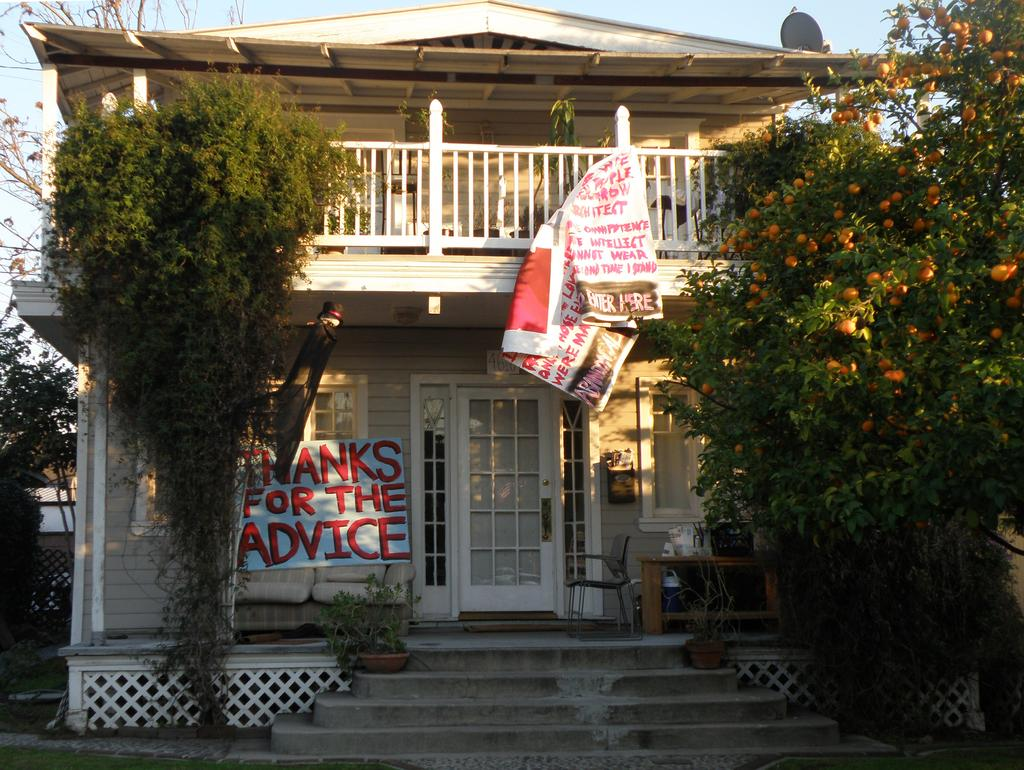Provide a one-sentence caption for the provided image. A house with a banner on the front that reads "Thanks for the advice". 